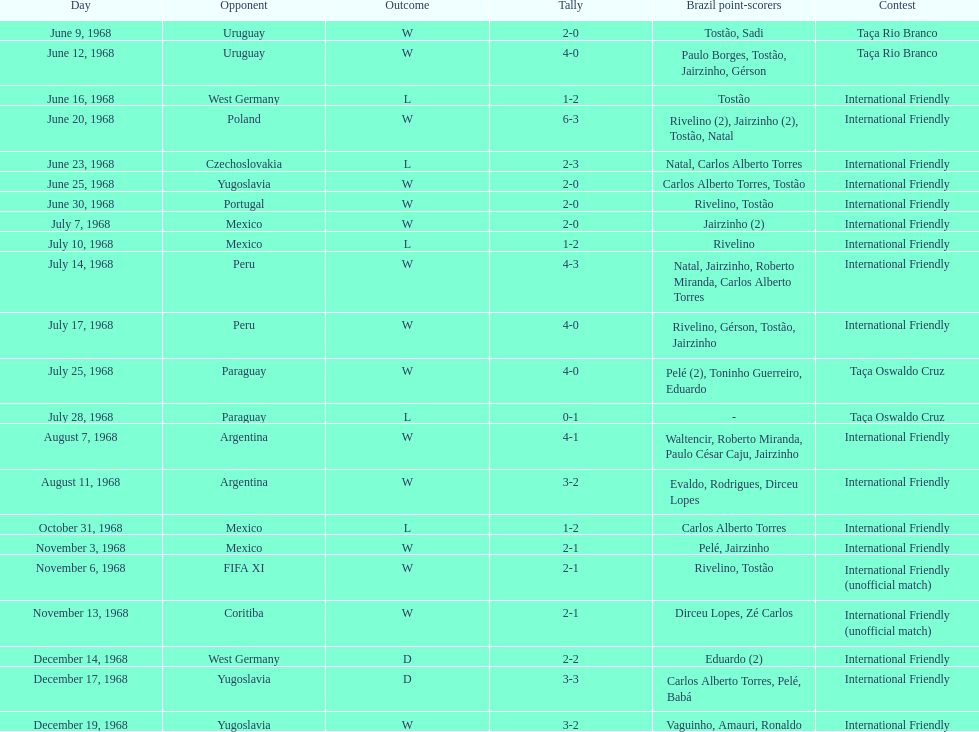How many matches are wins? 15. 